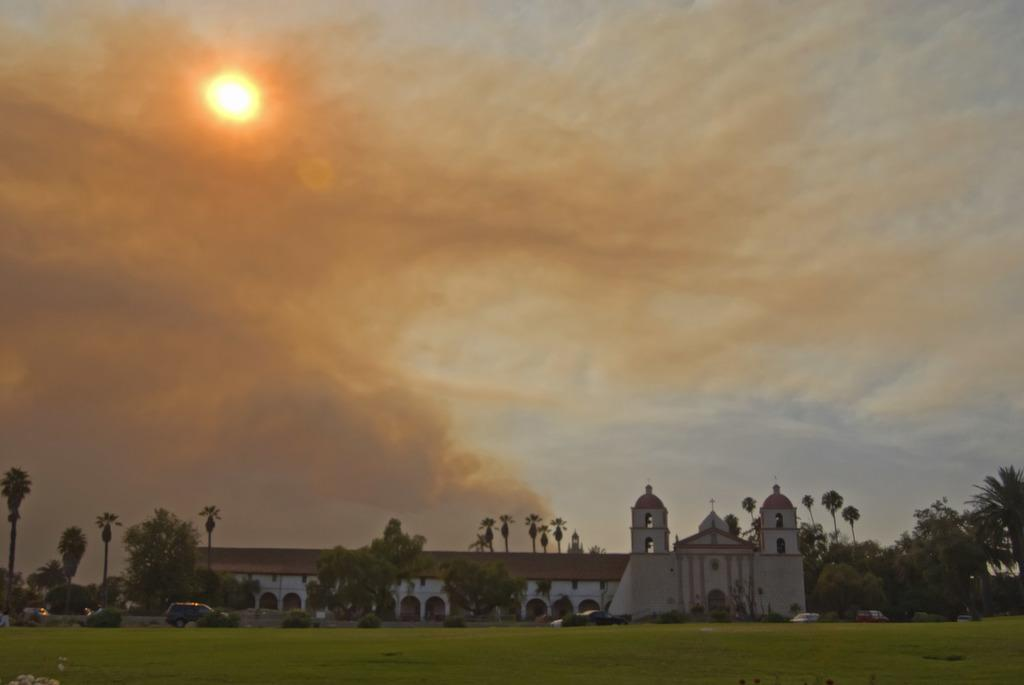What is the weather like in the image? The sky is cloudy in the image, indicating a potentially overcast or cloudy day. Can the sun be seen in the image despite the cloudy sky? Yes, the sun is visible in the image. What structures or objects are present at the bottom of the image? There is a house, trees, vehicles, plants, and grass visible at the bottom of the image. What type of powder is being used to lift the house in the image? There is no powder or lifting action involving the house in the image; it is simply a house situated at the bottom of the image. 